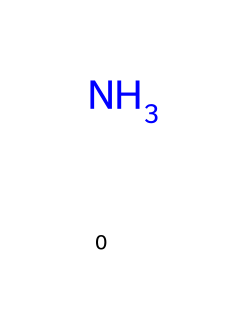What is the chemical name for this compound? The compound represented by the SMILES N is known as ammonia, which is a common refrigerant used in industrial refrigeration systems.
Answer: ammonia How many atoms are present in this molecule? The SMILES representation N indicates a single nitrogen atom, so the molecule has one atom in total.
Answer: 1 What type of bond is present in ammonia? Ammonia consists of a single nitrogen atom bonded to three hydrogen atoms through covalent bonds, but since the representation shows only nitrogen, it highlights the presence of nitrogen without detailing the hydrogen bonds.
Answer: covalent Is ammonia a polar or nonpolar molecule? Ammonia has a polar structure due to the presence of a lone pair on the nitrogen atom and the asymmetrical distribution of its hydrogen atoms, leading to a net dipole moment.
Answer: polar What is the typical use of ammonia in refrigeration? Ammonia is primarily used in refrigeration systems for its efficiency in absorbing heat and being economically viable for large-scale cooling applications.
Answer: refrigeration What is the molecular formula of ammonia? Given the structure, which includes one nitrogen and three hydrogen atoms, the molecular formula for ammonia can be deduced as NH3.
Answer: NH3 What property of ammonia makes it suitable as a refrigerant? The efficiency of ammonia as a refrigerant can be attributed to its high latent heat of vaporization, which enables it to absorb significant amounts of heat during phase change.
Answer: high latent heat 